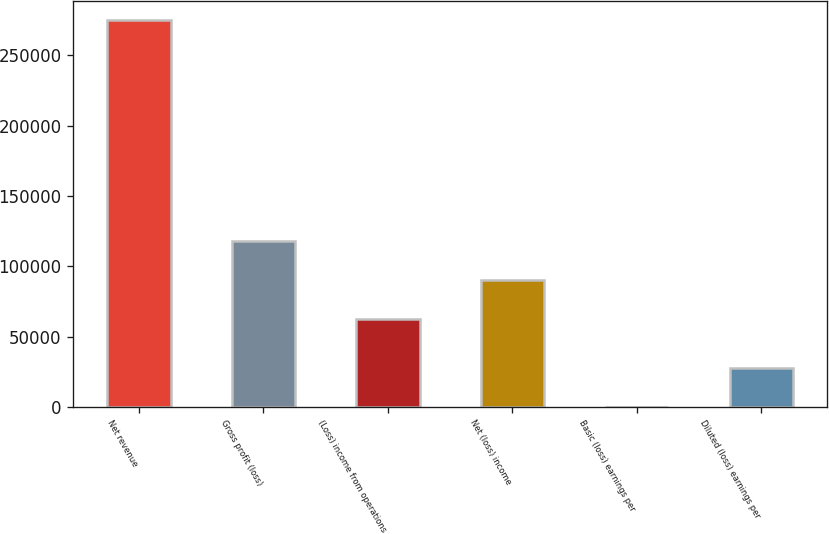Convert chart to OTSL. <chart><loc_0><loc_0><loc_500><loc_500><bar_chart><fcel>Net revenue<fcel>Gross profit (loss)<fcel>(Loss) income from operations<fcel>Net (loss) income<fcel>Basic (loss) earnings per<fcel>Diluted (loss) earnings per<nl><fcel>275297<fcel>117696<fcel>62637<fcel>90166.6<fcel>0.81<fcel>27530.4<nl></chart> 